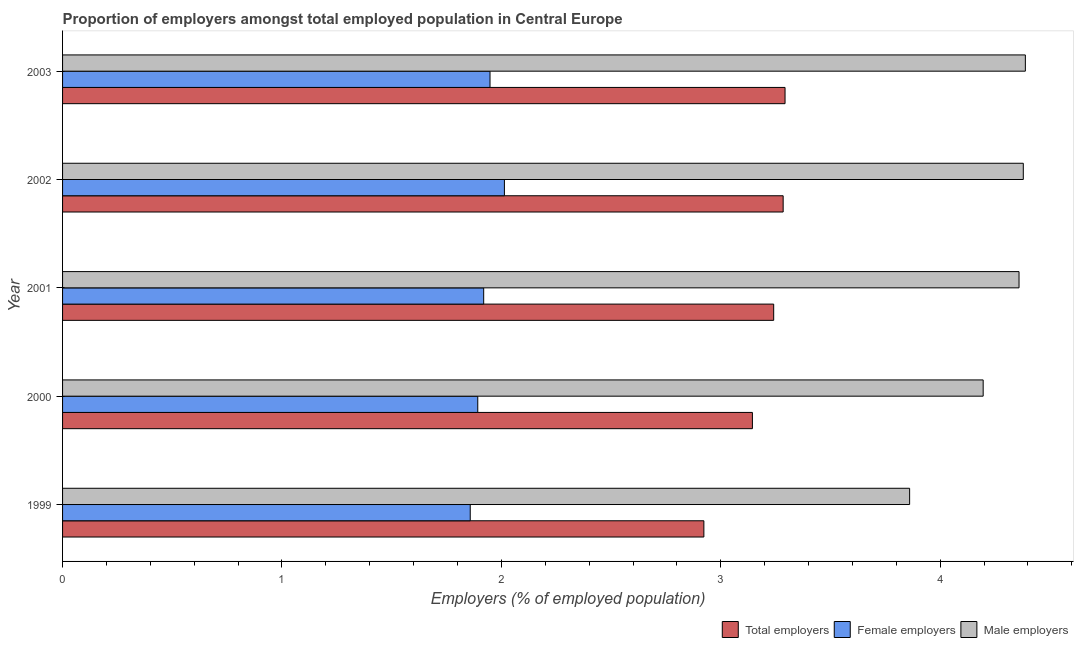How many bars are there on the 4th tick from the bottom?
Offer a terse response. 3. In how many cases, is the number of bars for a given year not equal to the number of legend labels?
Keep it short and to the point. 0. What is the percentage of male employers in 2001?
Provide a succinct answer. 4.36. Across all years, what is the maximum percentage of total employers?
Your answer should be very brief. 3.29. Across all years, what is the minimum percentage of total employers?
Offer a very short reply. 2.92. What is the total percentage of female employers in the graph?
Your answer should be compact. 9.63. What is the difference between the percentage of male employers in 2001 and that in 2003?
Your answer should be very brief. -0.03. What is the difference between the percentage of total employers in 2003 and the percentage of female employers in 1999?
Keep it short and to the point. 1.43. What is the average percentage of total employers per year?
Give a very brief answer. 3.18. In the year 2000, what is the difference between the percentage of total employers and percentage of female employers?
Your response must be concise. 1.25. In how many years, is the percentage of total employers greater than 2.2 %?
Offer a terse response. 5. What is the ratio of the percentage of male employers in 1999 to that in 2000?
Make the answer very short. 0.92. Is the percentage of male employers in 2002 less than that in 2003?
Your answer should be very brief. Yes. Is the difference between the percentage of male employers in 2002 and 2003 greater than the difference between the percentage of female employers in 2002 and 2003?
Offer a terse response. No. What is the difference between the highest and the second highest percentage of female employers?
Give a very brief answer. 0.07. What is the difference between the highest and the lowest percentage of total employers?
Your answer should be compact. 0.37. Is the sum of the percentage of male employers in 2001 and 2003 greater than the maximum percentage of female employers across all years?
Offer a very short reply. Yes. What does the 3rd bar from the top in 2003 represents?
Provide a short and direct response. Total employers. What does the 2nd bar from the bottom in 2000 represents?
Your answer should be compact. Female employers. Is it the case that in every year, the sum of the percentage of total employers and percentage of female employers is greater than the percentage of male employers?
Your answer should be very brief. Yes. How many bars are there?
Provide a succinct answer. 15. Are all the bars in the graph horizontal?
Keep it short and to the point. Yes. How many years are there in the graph?
Offer a very short reply. 5. What is the difference between two consecutive major ticks on the X-axis?
Offer a terse response. 1. Does the graph contain grids?
Give a very brief answer. No. Where does the legend appear in the graph?
Keep it short and to the point. Bottom right. How are the legend labels stacked?
Make the answer very short. Horizontal. What is the title of the graph?
Provide a short and direct response. Proportion of employers amongst total employed population in Central Europe. Does "Social Protection" appear as one of the legend labels in the graph?
Offer a terse response. No. What is the label or title of the X-axis?
Give a very brief answer. Employers (% of employed population). What is the Employers (% of employed population) in Total employers in 1999?
Provide a succinct answer. 2.92. What is the Employers (% of employed population) in Female employers in 1999?
Your answer should be very brief. 1.86. What is the Employers (% of employed population) in Male employers in 1999?
Your answer should be very brief. 3.86. What is the Employers (% of employed population) of Total employers in 2000?
Your answer should be compact. 3.14. What is the Employers (% of employed population) in Female employers in 2000?
Keep it short and to the point. 1.89. What is the Employers (% of employed population) of Male employers in 2000?
Keep it short and to the point. 4.2. What is the Employers (% of employed population) of Total employers in 2001?
Offer a terse response. 3.24. What is the Employers (% of employed population) in Female employers in 2001?
Provide a short and direct response. 1.92. What is the Employers (% of employed population) of Male employers in 2001?
Provide a short and direct response. 4.36. What is the Employers (% of employed population) of Total employers in 2002?
Your answer should be very brief. 3.28. What is the Employers (% of employed population) of Female employers in 2002?
Give a very brief answer. 2.01. What is the Employers (% of employed population) of Male employers in 2002?
Your answer should be very brief. 4.38. What is the Employers (% of employed population) in Total employers in 2003?
Your answer should be compact. 3.29. What is the Employers (% of employed population) of Female employers in 2003?
Your answer should be very brief. 1.95. What is the Employers (% of employed population) of Male employers in 2003?
Your answer should be very brief. 4.39. Across all years, what is the maximum Employers (% of employed population) in Total employers?
Offer a very short reply. 3.29. Across all years, what is the maximum Employers (% of employed population) in Female employers?
Keep it short and to the point. 2.01. Across all years, what is the maximum Employers (% of employed population) in Male employers?
Offer a terse response. 4.39. Across all years, what is the minimum Employers (% of employed population) in Total employers?
Offer a terse response. 2.92. Across all years, what is the minimum Employers (% of employed population) in Female employers?
Make the answer very short. 1.86. Across all years, what is the minimum Employers (% of employed population) in Male employers?
Provide a succinct answer. 3.86. What is the total Employers (% of employed population) of Total employers in the graph?
Offer a very short reply. 15.89. What is the total Employers (% of employed population) in Female employers in the graph?
Provide a short and direct response. 9.63. What is the total Employers (% of employed population) of Male employers in the graph?
Your answer should be compact. 21.18. What is the difference between the Employers (% of employed population) of Total employers in 1999 and that in 2000?
Make the answer very short. -0.22. What is the difference between the Employers (% of employed population) of Female employers in 1999 and that in 2000?
Provide a succinct answer. -0.03. What is the difference between the Employers (% of employed population) in Male employers in 1999 and that in 2000?
Provide a short and direct response. -0.34. What is the difference between the Employers (% of employed population) of Total employers in 1999 and that in 2001?
Ensure brevity in your answer.  -0.32. What is the difference between the Employers (% of employed population) of Female employers in 1999 and that in 2001?
Your answer should be compact. -0.06. What is the difference between the Employers (% of employed population) of Male employers in 1999 and that in 2001?
Ensure brevity in your answer.  -0.5. What is the difference between the Employers (% of employed population) in Total employers in 1999 and that in 2002?
Your answer should be very brief. -0.36. What is the difference between the Employers (% of employed population) of Female employers in 1999 and that in 2002?
Offer a terse response. -0.16. What is the difference between the Employers (% of employed population) in Male employers in 1999 and that in 2002?
Ensure brevity in your answer.  -0.52. What is the difference between the Employers (% of employed population) of Total employers in 1999 and that in 2003?
Ensure brevity in your answer.  -0.37. What is the difference between the Employers (% of employed population) in Female employers in 1999 and that in 2003?
Your answer should be compact. -0.09. What is the difference between the Employers (% of employed population) in Male employers in 1999 and that in 2003?
Give a very brief answer. -0.53. What is the difference between the Employers (% of employed population) in Total employers in 2000 and that in 2001?
Make the answer very short. -0.1. What is the difference between the Employers (% of employed population) of Female employers in 2000 and that in 2001?
Your response must be concise. -0.03. What is the difference between the Employers (% of employed population) in Male employers in 2000 and that in 2001?
Your answer should be compact. -0.16. What is the difference between the Employers (% of employed population) of Total employers in 2000 and that in 2002?
Ensure brevity in your answer.  -0.14. What is the difference between the Employers (% of employed population) in Female employers in 2000 and that in 2002?
Ensure brevity in your answer.  -0.12. What is the difference between the Employers (% of employed population) in Male employers in 2000 and that in 2002?
Your answer should be compact. -0.18. What is the difference between the Employers (% of employed population) of Total employers in 2000 and that in 2003?
Provide a succinct answer. -0.15. What is the difference between the Employers (% of employed population) in Female employers in 2000 and that in 2003?
Keep it short and to the point. -0.06. What is the difference between the Employers (% of employed population) of Male employers in 2000 and that in 2003?
Provide a short and direct response. -0.19. What is the difference between the Employers (% of employed population) of Total employers in 2001 and that in 2002?
Provide a short and direct response. -0.04. What is the difference between the Employers (% of employed population) in Female employers in 2001 and that in 2002?
Your answer should be compact. -0.09. What is the difference between the Employers (% of employed population) of Male employers in 2001 and that in 2002?
Give a very brief answer. -0.02. What is the difference between the Employers (% of employed population) of Total employers in 2001 and that in 2003?
Provide a succinct answer. -0.05. What is the difference between the Employers (% of employed population) in Female employers in 2001 and that in 2003?
Offer a terse response. -0.03. What is the difference between the Employers (% of employed population) of Male employers in 2001 and that in 2003?
Your response must be concise. -0.03. What is the difference between the Employers (% of employed population) of Total employers in 2002 and that in 2003?
Give a very brief answer. -0.01. What is the difference between the Employers (% of employed population) in Female employers in 2002 and that in 2003?
Provide a short and direct response. 0.07. What is the difference between the Employers (% of employed population) in Male employers in 2002 and that in 2003?
Give a very brief answer. -0.01. What is the difference between the Employers (% of employed population) in Total employers in 1999 and the Employers (% of employed population) in Female employers in 2000?
Your response must be concise. 1.03. What is the difference between the Employers (% of employed population) of Total employers in 1999 and the Employers (% of employed population) of Male employers in 2000?
Keep it short and to the point. -1.27. What is the difference between the Employers (% of employed population) in Female employers in 1999 and the Employers (% of employed population) in Male employers in 2000?
Your response must be concise. -2.34. What is the difference between the Employers (% of employed population) in Total employers in 1999 and the Employers (% of employed population) in Female employers in 2001?
Offer a terse response. 1. What is the difference between the Employers (% of employed population) in Total employers in 1999 and the Employers (% of employed population) in Male employers in 2001?
Offer a very short reply. -1.44. What is the difference between the Employers (% of employed population) in Female employers in 1999 and the Employers (% of employed population) in Male employers in 2001?
Your response must be concise. -2.5. What is the difference between the Employers (% of employed population) in Total employers in 1999 and the Employers (% of employed population) in Female employers in 2002?
Your answer should be compact. 0.91. What is the difference between the Employers (% of employed population) of Total employers in 1999 and the Employers (% of employed population) of Male employers in 2002?
Your answer should be very brief. -1.46. What is the difference between the Employers (% of employed population) in Female employers in 1999 and the Employers (% of employed population) in Male employers in 2002?
Provide a succinct answer. -2.52. What is the difference between the Employers (% of employed population) in Total employers in 1999 and the Employers (% of employed population) in Female employers in 2003?
Offer a terse response. 0.97. What is the difference between the Employers (% of employed population) in Total employers in 1999 and the Employers (% of employed population) in Male employers in 2003?
Your answer should be compact. -1.47. What is the difference between the Employers (% of employed population) in Female employers in 1999 and the Employers (% of employed population) in Male employers in 2003?
Provide a succinct answer. -2.53. What is the difference between the Employers (% of employed population) in Total employers in 2000 and the Employers (% of employed population) in Female employers in 2001?
Give a very brief answer. 1.22. What is the difference between the Employers (% of employed population) of Total employers in 2000 and the Employers (% of employed population) of Male employers in 2001?
Ensure brevity in your answer.  -1.22. What is the difference between the Employers (% of employed population) of Female employers in 2000 and the Employers (% of employed population) of Male employers in 2001?
Offer a very short reply. -2.47. What is the difference between the Employers (% of employed population) of Total employers in 2000 and the Employers (% of employed population) of Female employers in 2002?
Your answer should be very brief. 1.13. What is the difference between the Employers (% of employed population) of Total employers in 2000 and the Employers (% of employed population) of Male employers in 2002?
Ensure brevity in your answer.  -1.23. What is the difference between the Employers (% of employed population) of Female employers in 2000 and the Employers (% of employed population) of Male employers in 2002?
Ensure brevity in your answer.  -2.49. What is the difference between the Employers (% of employed population) in Total employers in 2000 and the Employers (% of employed population) in Female employers in 2003?
Offer a very short reply. 1.2. What is the difference between the Employers (% of employed population) of Total employers in 2000 and the Employers (% of employed population) of Male employers in 2003?
Keep it short and to the point. -1.24. What is the difference between the Employers (% of employed population) in Female employers in 2000 and the Employers (% of employed population) in Male employers in 2003?
Give a very brief answer. -2.5. What is the difference between the Employers (% of employed population) of Total employers in 2001 and the Employers (% of employed population) of Female employers in 2002?
Keep it short and to the point. 1.23. What is the difference between the Employers (% of employed population) in Total employers in 2001 and the Employers (% of employed population) in Male employers in 2002?
Keep it short and to the point. -1.14. What is the difference between the Employers (% of employed population) of Female employers in 2001 and the Employers (% of employed population) of Male employers in 2002?
Your answer should be compact. -2.46. What is the difference between the Employers (% of employed population) in Total employers in 2001 and the Employers (% of employed population) in Female employers in 2003?
Your answer should be very brief. 1.29. What is the difference between the Employers (% of employed population) of Total employers in 2001 and the Employers (% of employed population) of Male employers in 2003?
Offer a terse response. -1.15. What is the difference between the Employers (% of employed population) in Female employers in 2001 and the Employers (% of employed population) in Male employers in 2003?
Provide a short and direct response. -2.47. What is the difference between the Employers (% of employed population) of Total employers in 2002 and the Employers (% of employed population) of Female employers in 2003?
Provide a succinct answer. 1.34. What is the difference between the Employers (% of employed population) of Total employers in 2002 and the Employers (% of employed population) of Male employers in 2003?
Provide a succinct answer. -1.1. What is the difference between the Employers (% of employed population) of Female employers in 2002 and the Employers (% of employed population) of Male employers in 2003?
Provide a succinct answer. -2.37. What is the average Employers (% of employed population) of Total employers per year?
Your response must be concise. 3.18. What is the average Employers (% of employed population) in Female employers per year?
Ensure brevity in your answer.  1.93. What is the average Employers (% of employed population) of Male employers per year?
Ensure brevity in your answer.  4.24. In the year 1999, what is the difference between the Employers (% of employed population) of Total employers and Employers (% of employed population) of Female employers?
Provide a short and direct response. 1.06. In the year 1999, what is the difference between the Employers (% of employed population) in Total employers and Employers (% of employed population) in Male employers?
Your answer should be compact. -0.94. In the year 1999, what is the difference between the Employers (% of employed population) in Female employers and Employers (% of employed population) in Male employers?
Your answer should be very brief. -2. In the year 2000, what is the difference between the Employers (% of employed population) in Total employers and Employers (% of employed population) in Female employers?
Offer a terse response. 1.25. In the year 2000, what is the difference between the Employers (% of employed population) in Total employers and Employers (% of employed population) in Male employers?
Provide a short and direct response. -1.05. In the year 2000, what is the difference between the Employers (% of employed population) of Female employers and Employers (% of employed population) of Male employers?
Offer a terse response. -2.3. In the year 2001, what is the difference between the Employers (% of employed population) in Total employers and Employers (% of employed population) in Female employers?
Keep it short and to the point. 1.32. In the year 2001, what is the difference between the Employers (% of employed population) of Total employers and Employers (% of employed population) of Male employers?
Keep it short and to the point. -1.12. In the year 2001, what is the difference between the Employers (% of employed population) of Female employers and Employers (% of employed population) of Male employers?
Give a very brief answer. -2.44. In the year 2002, what is the difference between the Employers (% of employed population) in Total employers and Employers (% of employed population) in Female employers?
Provide a succinct answer. 1.27. In the year 2002, what is the difference between the Employers (% of employed population) in Total employers and Employers (% of employed population) in Male employers?
Provide a succinct answer. -1.09. In the year 2002, what is the difference between the Employers (% of employed population) in Female employers and Employers (% of employed population) in Male employers?
Your response must be concise. -2.37. In the year 2003, what is the difference between the Employers (% of employed population) of Total employers and Employers (% of employed population) of Female employers?
Give a very brief answer. 1.34. In the year 2003, what is the difference between the Employers (% of employed population) of Total employers and Employers (% of employed population) of Male employers?
Your answer should be very brief. -1.1. In the year 2003, what is the difference between the Employers (% of employed population) in Female employers and Employers (% of employed population) in Male employers?
Your answer should be compact. -2.44. What is the ratio of the Employers (% of employed population) of Total employers in 1999 to that in 2000?
Your response must be concise. 0.93. What is the ratio of the Employers (% of employed population) of Female employers in 1999 to that in 2000?
Make the answer very short. 0.98. What is the ratio of the Employers (% of employed population) of Male employers in 1999 to that in 2000?
Make the answer very short. 0.92. What is the ratio of the Employers (% of employed population) of Total employers in 1999 to that in 2001?
Offer a terse response. 0.9. What is the ratio of the Employers (% of employed population) in Male employers in 1999 to that in 2001?
Offer a very short reply. 0.89. What is the ratio of the Employers (% of employed population) of Total employers in 1999 to that in 2002?
Offer a very short reply. 0.89. What is the ratio of the Employers (% of employed population) in Female employers in 1999 to that in 2002?
Provide a short and direct response. 0.92. What is the ratio of the Employers (% of employed population) in Male employers in 1999 to that in 2002?
Provide a short and direct response. 0.88. What is the ratio of the Employers (% of employed population) of Total employers in 1999 to that in 2003?
Give a very brief answer. 0.89. What is the ratio of the Employers (% of employed population) of Female employers in 1999 to that in 2003?
Make the answer very short. 0.95. What is the ratio of the Employers (% of employed population) in Male employers in 1999 to that in 2003?
Keep it short and to the point. 0.88. What is the ratio of the Employers (% of employed population) in Total employers in 2000 to that in 2001?
Give a very brief answer. 0.97. What is the ratio of the Employers (% of employed population) in Female employers in 2000 to that in 2001?
Offer a very short reply. 0.99. What is the ratio of the Employers (% of employed population) of Male employers in 2000 to that in 2001?
Offer a terse response. 0.96. What is the ratio of the Employers (% of employed population) in Total employers in 2000 to that in 2002?
Your response must be concise. 0.96. What is the ratio of the Employers (% of employed population) of Female employers in 2000 to that in 2002?
Offer a terse response. 0.94. What is the ratio of the Employers (% of employed population) in Male employers in 2000 to that in 2002?
Your answer should be very brief. 0.96. What is the ratio of the Employers (% of employed population) in Total employers in 2000 to that in 2003?
Offer a terse response. 0.95. What is the ratio of the Employers (% of employed population) of Female employers in 2000 to that in 2003?
Make the answer very short. 0.97. What is the ratio of the Employers (% of employed population) in Male employers in 2000 to that in 2003?
Ensure brevity in your answer.  0.96. What is the ratio of the Employers (% of employed population) in Total employers in 2001 to that in 2002?
Your answer should be very brief. 0.99. What is the ratio of the Employers (% of employed population) in Female employers in 2001 to that in 2002?
Provide a short and direct response. 0.95. What is the ratio of the Employers (% of employed population) in Total employers in 2001 to that in 2003?
Give a very brief answer. 0.98. What is the ratio of the Employers (% of employed population) in Female employers in 2001 to that in 2003?
Keep it short and to the point. 0.99. What is the ratio of the Employers (% of employed population) in Male employers in 2001 to that in 2003?
Ensure brevity in your answer.  0.99. What is the ratio of the Employers (% of employed population) in Total employers in 2002 to that in 2003?
Provide a succinct answer. 1. What is the ratio of the Employers (% of employed population) of Female employers in 2002 to that in 2003?
Your answer should be compact. 1.03. What is the ratio of the Employers (% of employed population) in Male employers in 2002 to that in 2003?
Your answer should be compact. 1. What is the difference between the highest and the second highest Employers (% of employed population) in Total employers?
Make the answer very short. 0.01. What is the difference between the highest and the second highest Employers (% of employed population) of Female employers?
Offer a terse response. 0.07. What is the difference between the highest and the second highest Employers (% of employed population) of Male employers?
Make the answer very short. 0.01. What is the difference between the highest and the lowest Employers (% of employed population) in Total employers?
Make the answer very short. 0.37. What is the difference between the highest and the lowest Employers (% of employed population) of Female employers?
Make the answer very short. 0.16. What is the difference between the highest and the lowest Employers (% of employed population) of Male employers?
Make the answer very short. 0.53. 